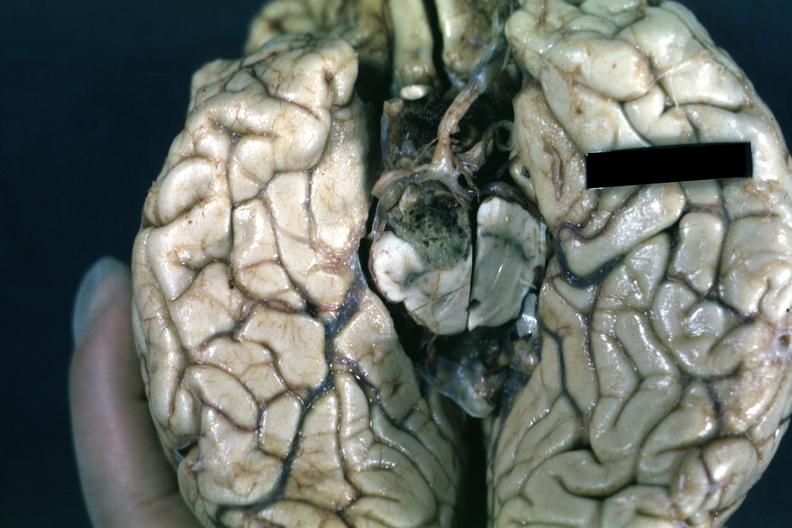does this image show fixed tissue inferior view of cerebral hemisphere with cerebellum and brainstexcised?
Answer the question using a single word or phrase. Yes 